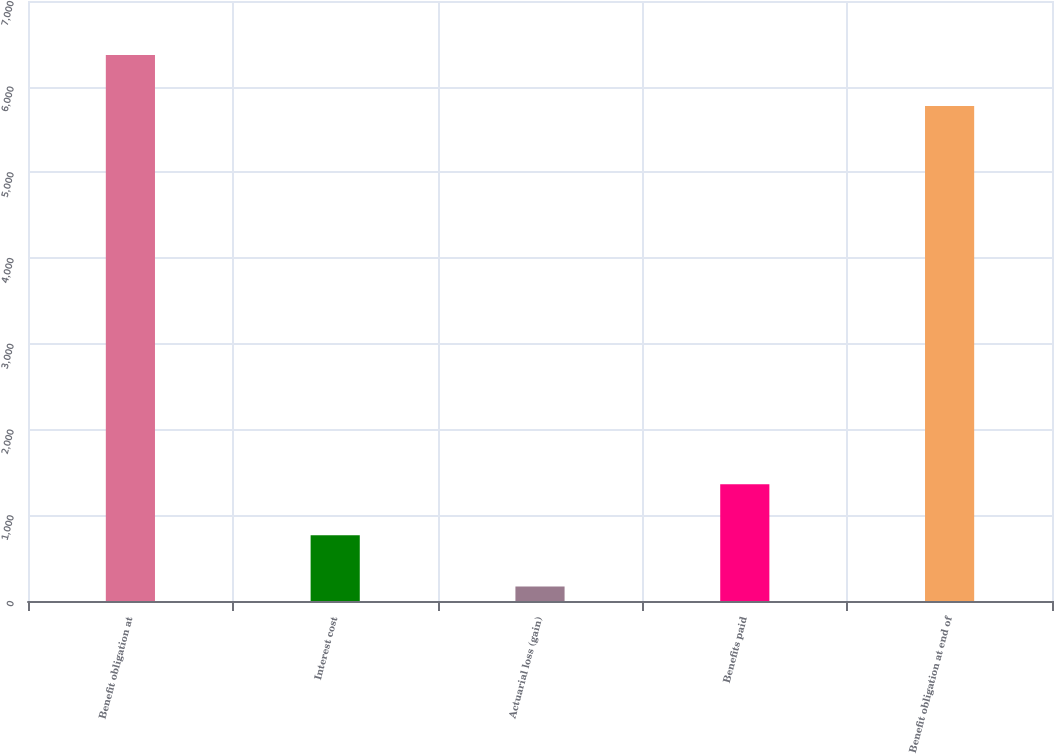Convert chart to OTSL. <chart><loc_0><loc_0><loc_500><loc_500><bar_chart><fcel>Benefit obligation at<fcel>Interest cost<fcel>Actuarial loss (gain)<fcel>Benefits paid<fcel>Benefit obligation at end of<nl><fcel>6371.1<fcel>766.1<fcel>169<fcel>1363.2<fcel>5774<nl></chart> 